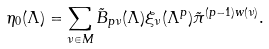<formula> <loc_0><loc_0><loc_500><loc_500>\eta _ { 0 } ( \Lambda ) = \sum _ { \nu \in M } \tilde { B } _ { p \nu } ( \Lambda ) \xi _ { \nu } ( \Lambda ^ { p } ) \tilde { \pi } ^ { ( p - 1 ) w ( \nu ) } .</formula> 